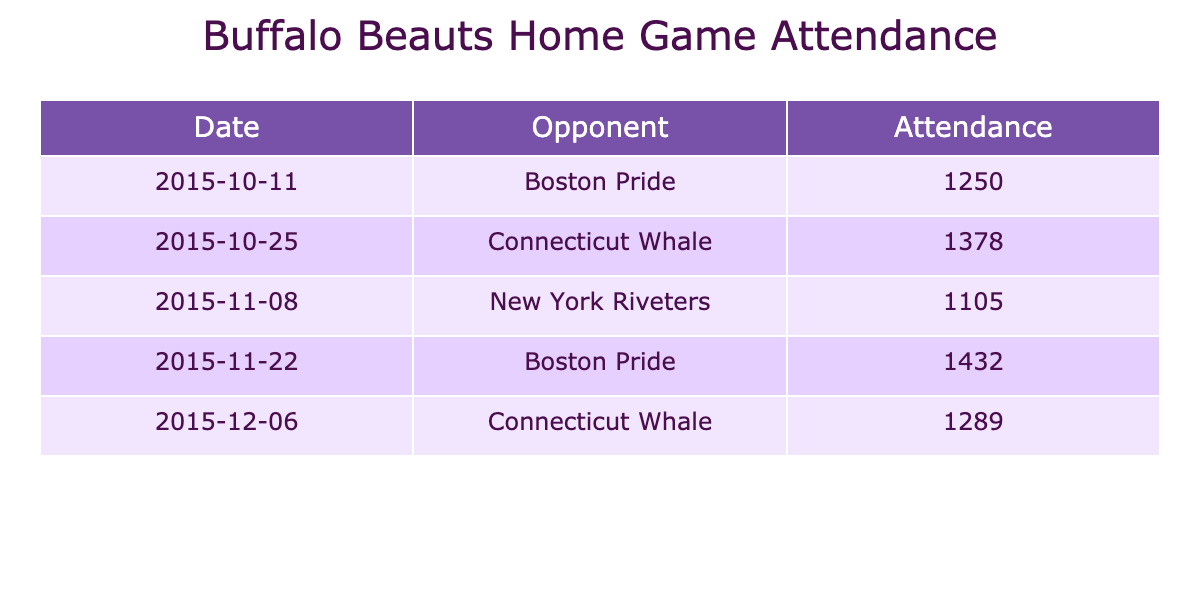What was the attendance for the first home game against the Boston Pride? The first home game listed in the table is against the Boston Pride on October 11, 2015, with an attendance of 1250.
Answer: 1250 What was the total attendance for all five games? Adding the attendance figures for all five games: 1250 + 1378 + 1105 + 1432 + 1289 = 6454.
Answer: 6454 Which game had the highest attendance? By examining the attendance figures, the game with the highest attendance is the matchup against the Boston Pride on November 22, with 1432 attendees.
Answer: 1432 What is the average attendance across the five home games? To find the average, add the total attendance (6454) and divide by the number of games (5): 6454 / 5 = 1290.8.
Answer: 1290.8 Did the attendance increase in the second home game compared to the first? The first game had an attendance of 1250, and the second game had an attendance of 1378, which is an increase of 128.
Answer: Yes What is the difference in attendance between the first and last game? The first game had an attendance of 1250 and the last game (against Connecticut Whale on December 6) had 1289, so the difference is 1289 - 1250 = 39.
Answer: 39 How many games had an attendance below 1300? The games with attendance below 1300 were against New York Riveters (1105) and Boston Pride (1250), totaling 2 games.
Answer: 2 What was the attendance trend over the first five games? The attendance figures are: 1250, 1378, 1105, 1432, 1289. The trend shows fluctuations with a peak at 1432 and a dip at 1105.
Answer: Fluctuating Was the attendance for the second game higher than the attendance for the fourth game? The second game (1378) had lower attendance than the fourth game (1432), so the answer is no.
Answer: No If the fifth game's attendance increased by 100, what would the new attendance figure be? The fifth game's attendance is currently 1289. If it increased by 100, the new figure would be 1289 + 100 = 1389.
Answer: 1389 